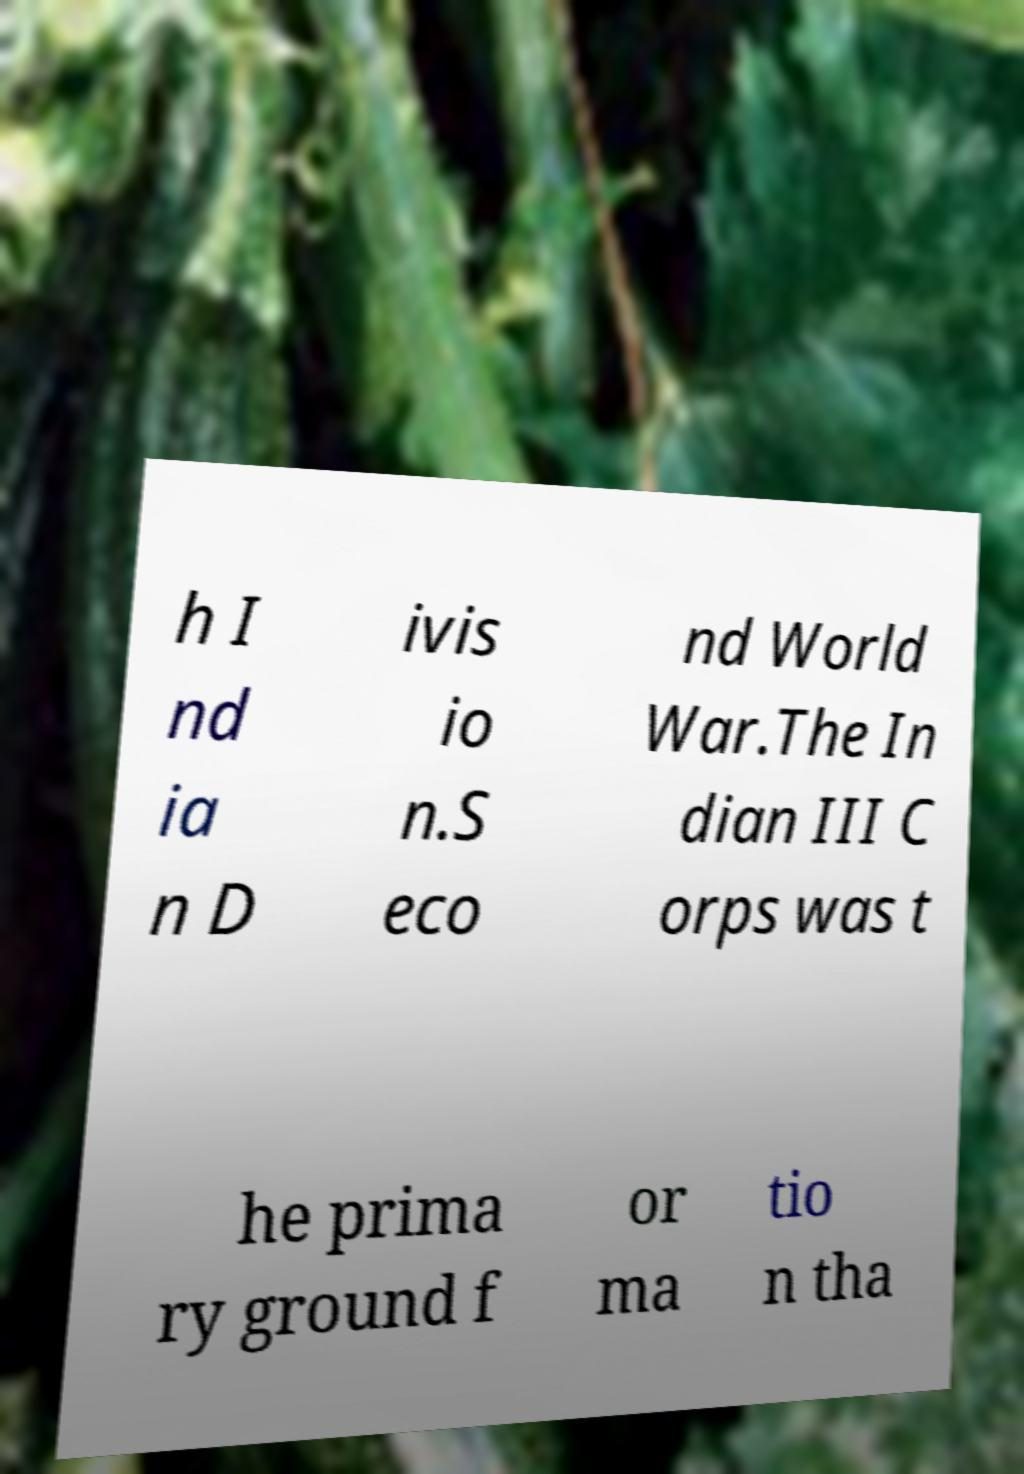Please read and relay the text visible in this image. What does it say? h I nd ia n D ivis io n.S eco nd World War.The In dian III C orps was t he prima ry ground f or ma tio n tha 